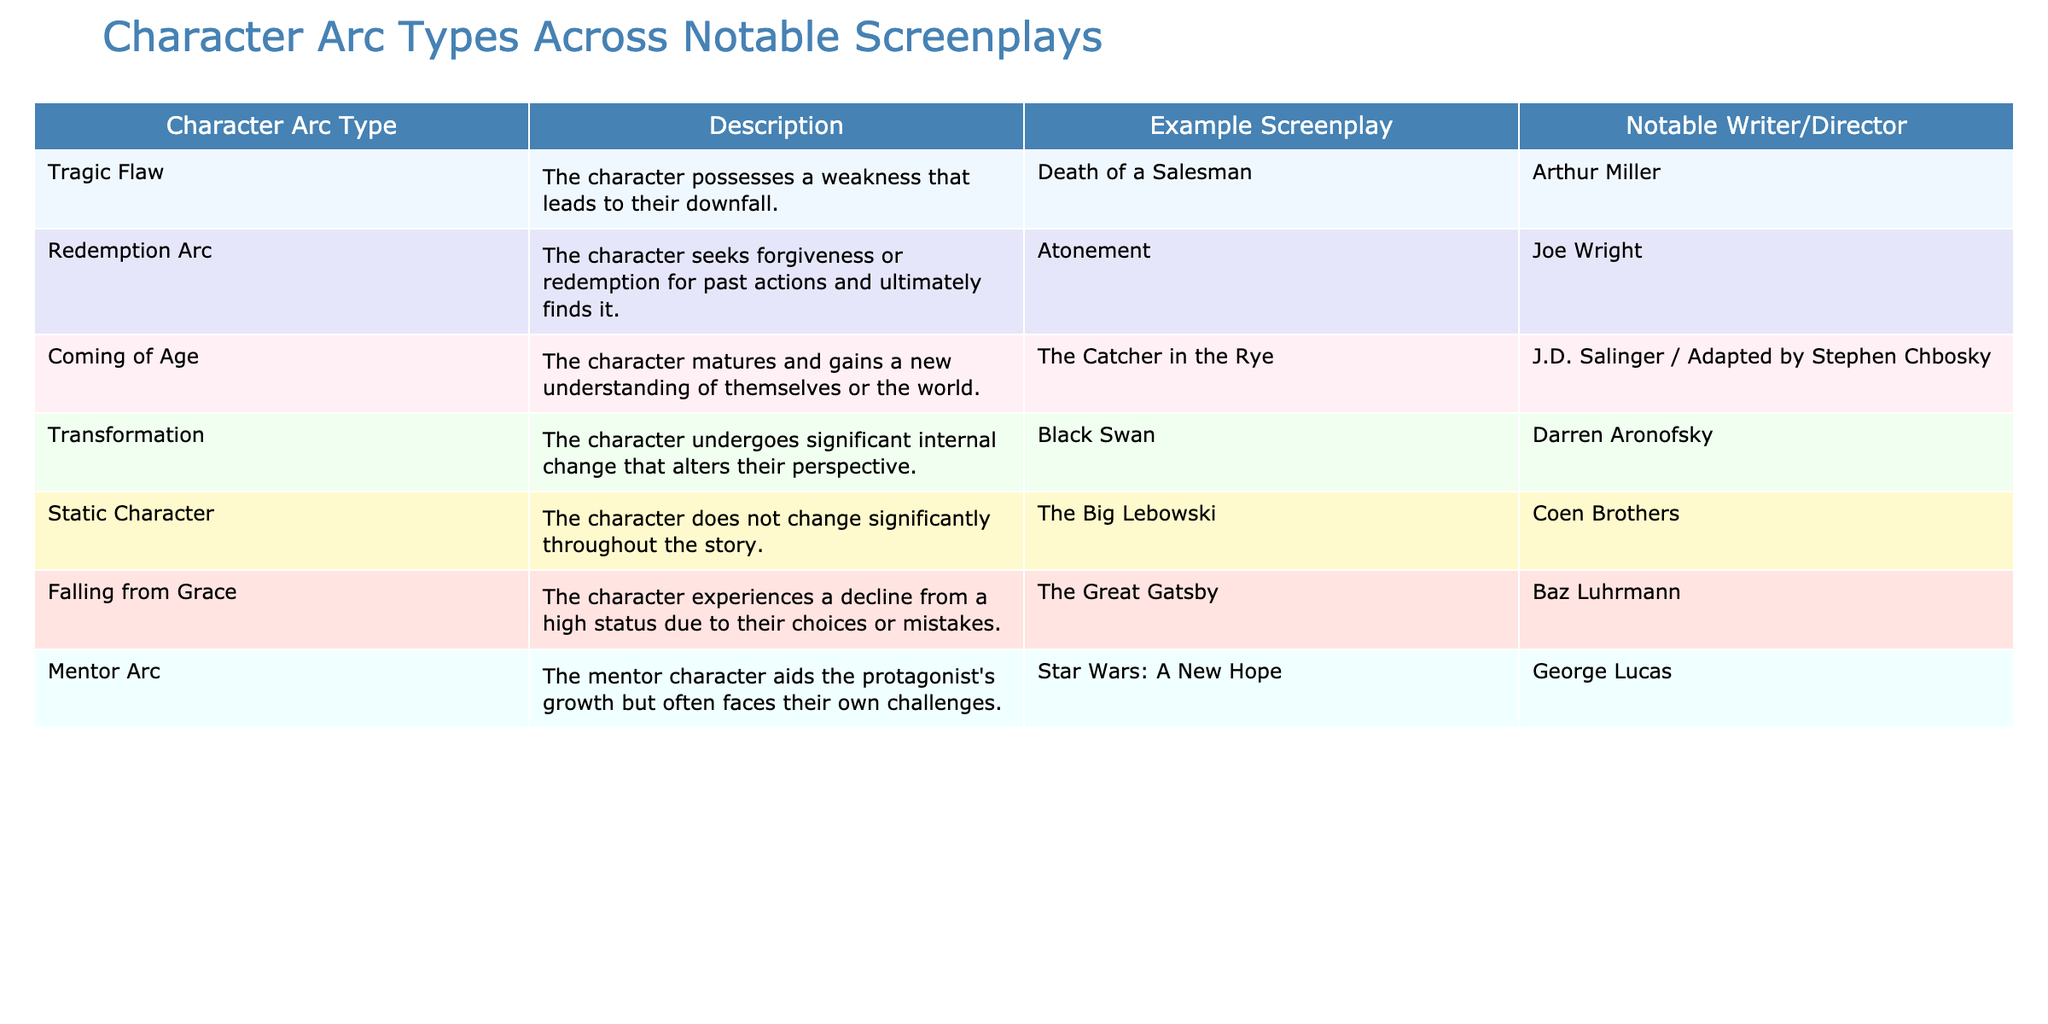What character arc type is exemplified by "Death of a Salesman"? By referring to the table, we see that "Death of a Salesman" is listed under the "Tragic Flaw" character arc type.
Answer: Tragic Flaw Who is the notable writer/director for "Atonement"? The table indicates that "Atonement" is associated with the writer/director Joe Wright.
Answer: Joe Wright Is "The Big Lebowski" an example of a character that changes significantly throughout the story? According to the table, "The Big Lebowski" is categorized as a "Static Character," implying that the character does not change significantly.
Answer: No What are the two character arc types that involve significant internal change? Looking at the table, the "Transformation" and "Redemption Arc" types involve significant internal change where the character transforms or seeks forgiveness, respectively.
Answer: Transformation, Redemption Arc Which example screenplay has a mentor character aiding the protagonist's growth? From the table, "Star Wars: A New Hope" exemplifies a mentor arc type, where the mentor character aids the protagonist's growth.
Answer: Star Wars: A New Hope Determine the number of screenplays that involve a character falling from grace. By reviewing the table, "Falling from Grace" is represented by only one screenplay, "The Great Gatsby." So, there is just one entry.
Answer: 1 Does the "Coming of Age" character arc type typically signify a character that gains a new understanding of themselves? The table explicitly states that "Coming of Age" characters mature and gain new understanding, which confirms this fact.
Answer: Yes What percentage of the arcs presented in the table are about characters seeking redemption? The table shows one example of "Redemption Arc" from the total of eight entries. The percentage is calculated as (1/8)*100 = 12.5%.
Answer: 12.5% How would you categorize a character in "Black Swan"? The table categorizes "Black Swan" under the "Transformation" arc type, as it involves significant internal change that alters the character's perspective.
Answer: Transformation 